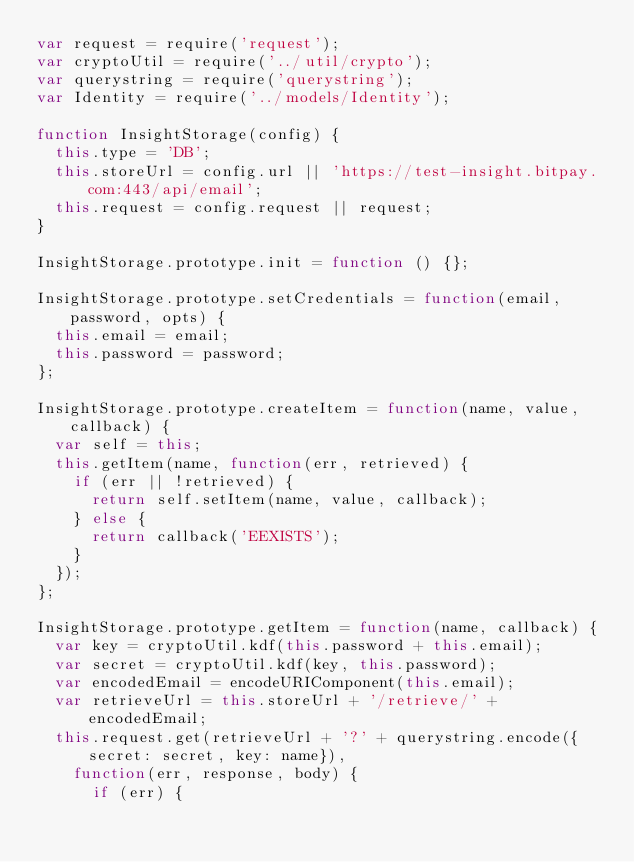Convert code to text. <code><loc_0><loc_0><loc_500><loc_500><_JavaScript_>var request = require('request');
var cryptoUtil = require('../util/crypto');
var querystring = require('querystring');
var Identity = require('../models/Identity');

function InsightStorage(config) {
  this.type = 'DB';
  this.storeUrl = config.url || 'https://test-insight.bitpay.com:443/api/email';
  this.request = config.request || request;
}

InsightStorage.prototype.init = function () {};

InsightStorage.prototype.setCredentials = function(email, password, opts) {
  this.email = email;
  this.password = password;
};

InsightStorage.prototype.createItem = function(name, value, callback) {
  var self = this;
  this.getItem(name, function(err, retrieved) {
    if (err || !retrieved) {
      return self.setItem(name, value, callback);
    } else {
      return callback('EEXISTS');
    }
  });
};

InsightStorage.prototype.getItem = function(name, callback) {
  var key = cryptoUtil.kdf(this.password + this.email);
  var secret = cryptoUtil.kdf(key, this.password);
  var encodedEmail = encodeURIComponent(this.email);
  var retrieveUrl = this.storeUrl + '/retrieve/' + encodedEmail;
  this.request.get(retrieveUrl + '?' + querystring.encode({secret: secret, key: name}),
    function(err, response, body) {
      if (err) {</code> 